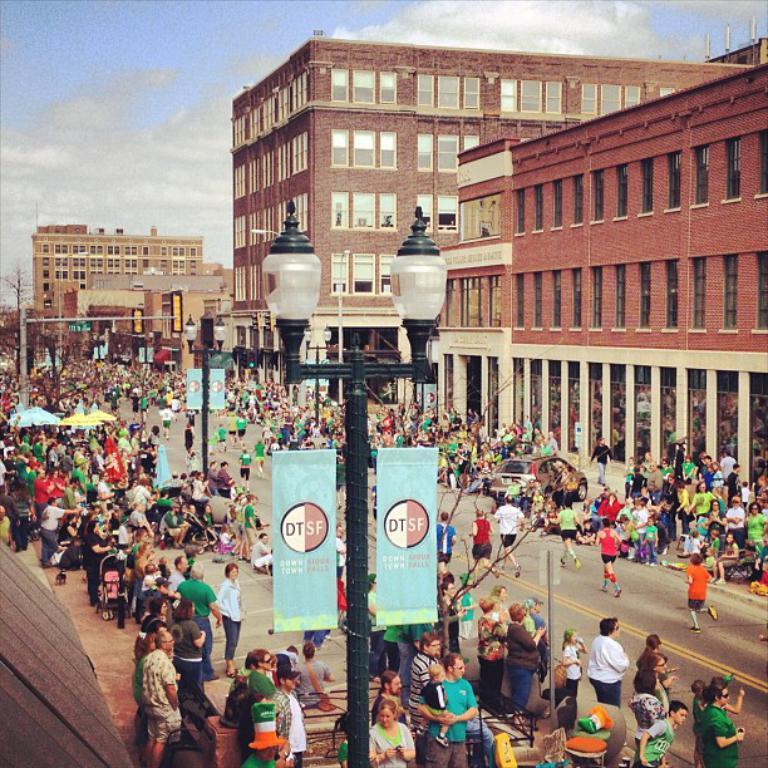Describe this image in one or two sentences. This is a street view. In this there are many people. There is a road and there is a street light pole with something changed on that. In the background there are buildings with pillars. And there is sky with clouds in the background. 